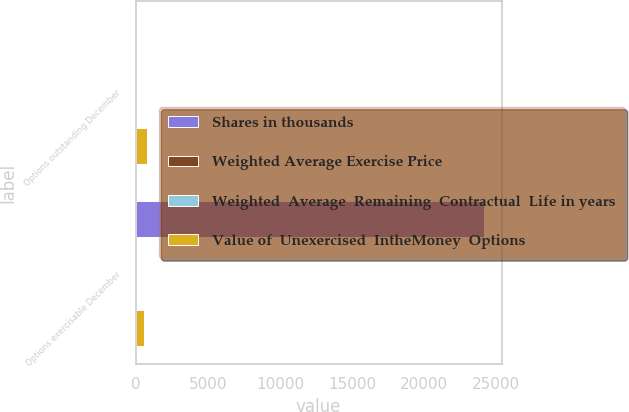<chart> <loc_0><loc_0><loc_500><loc_500><stacked_bar_chart><ecel><fcel>Options outstanding December<fcel>Options exercisable December<nl><fcel>Shares in thousands<fcel>47<fcel>24151<nl><fcel>Weighted Average Exercise Price<fcel>47<fcel>42<nl><fcel>Weighted  Average  Remaining  Contractual  Life in years<fcel>4<fcel>3<nl><fcel>Value of  Unexercised  IntheMoney  Options<fcel>773<fcel>572<nl></chart> 